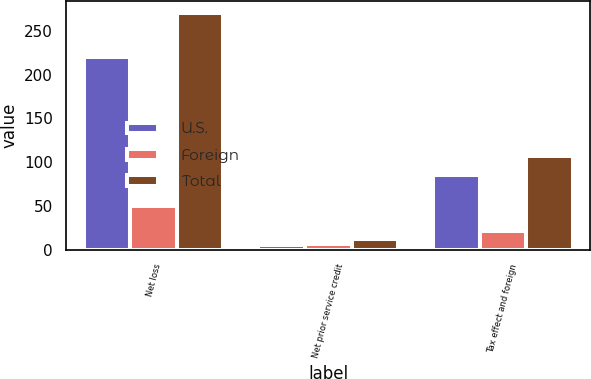Convert chart. <chart><loc_0><loc_0><loc_500><loc_500><stacked_bar_chart><ecel><fcel>Net loss<fcel>Net prior service credit<fcel>Tax effect and foreign<nl><fcel>U.S.<fcel>220.2<fcel>5.7<fcel>85<nl><fcel>Foreign<fcel>50.3<fcel>6.3<fcel>21.7<nl><fcel>Total<fcel>270.5<fcel>12<fcel>106.7<nl></chart> 